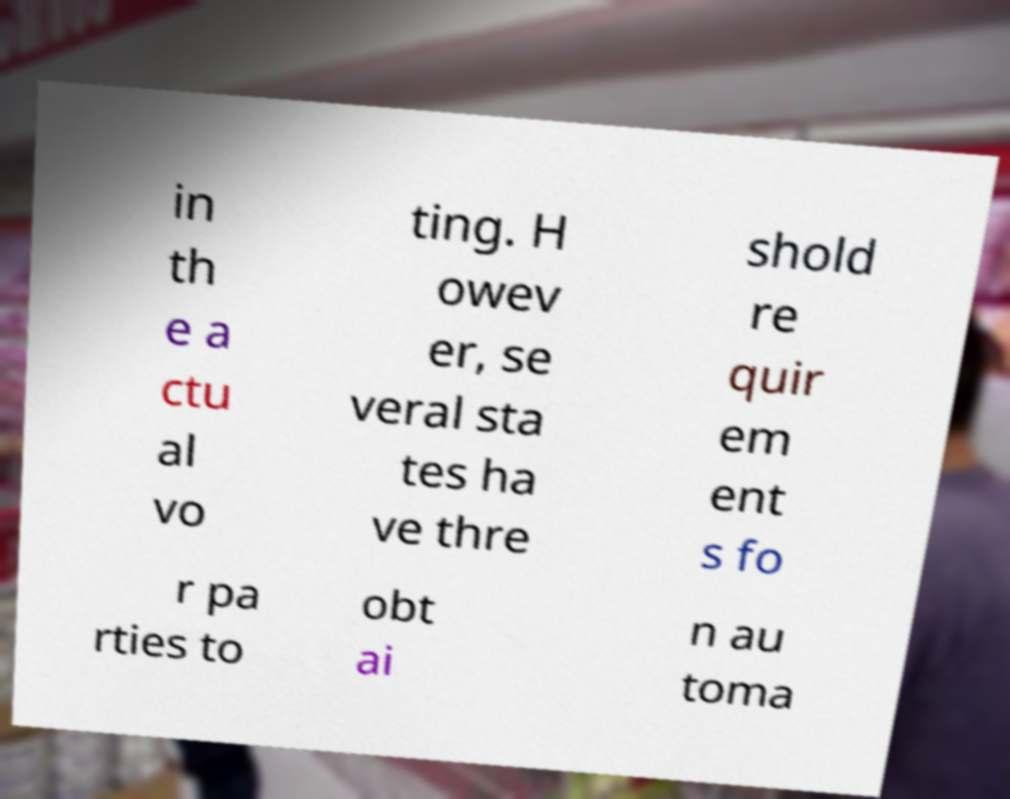Please read and relay the text visible in this image. What does it say? in th e a ctu al vo ting. H owev er, se veral sta tes ha ve thre shold re quir em ent s fo r pa rties to obt ai n au toma 